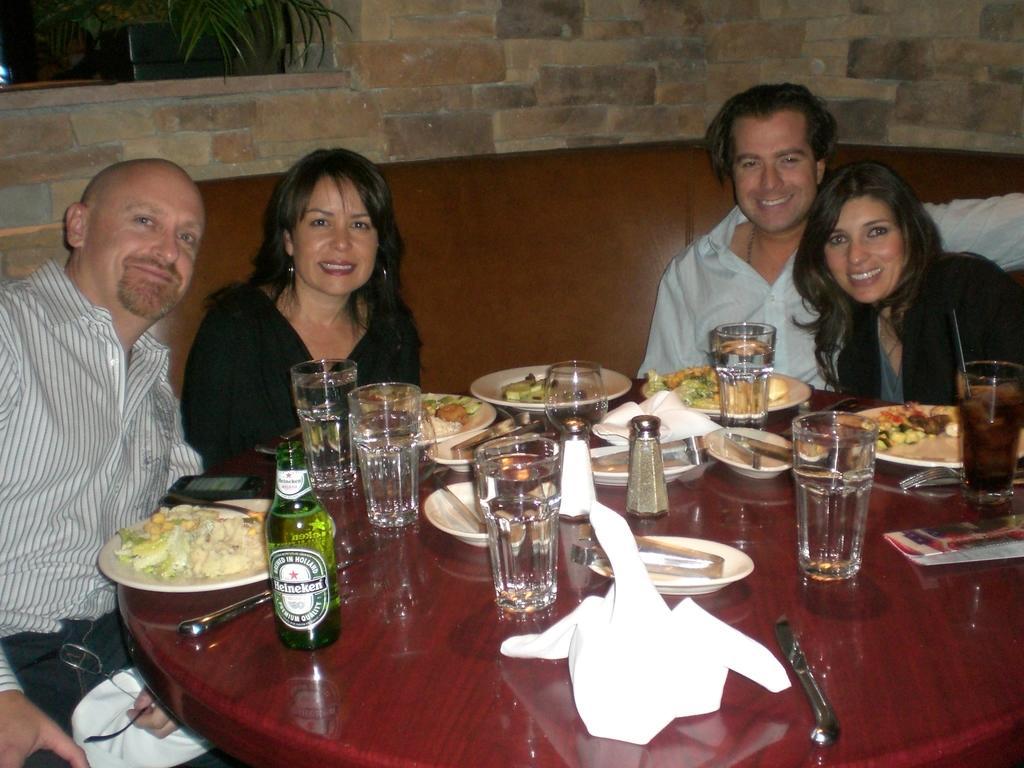Please provide a concise description of this image. In this picture there are two gents and two ladies are sitting on a sofa. In front of them there is a table. On the table there are glasses, tissues, bottle, plate, a food item in a plate, a mobile phone, a small jar bowl , a paper , fork. Behind there are brick wall and leaves on the top. 